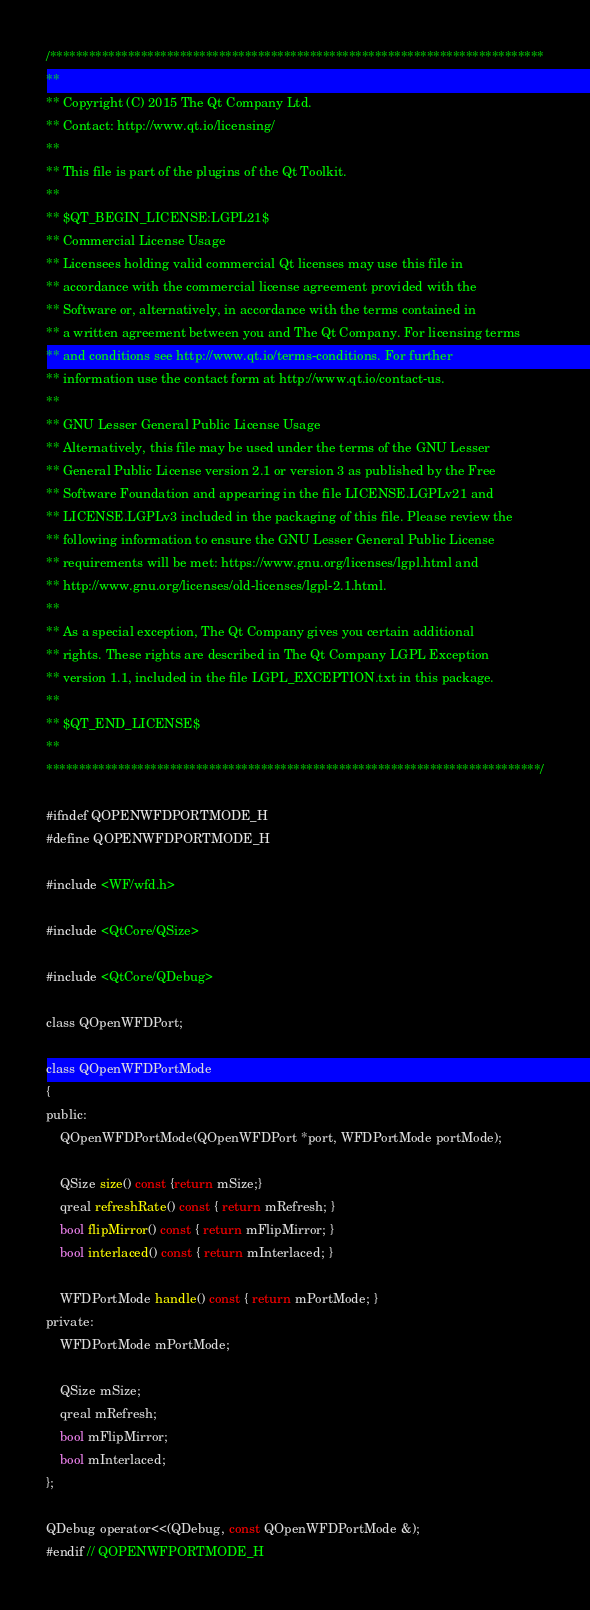Convert code to text. <code><loc_0><loc_0><loc_500><loc_500><_C_>/****************************************************************************
**
** Copyright (C) 2015 The Qt Company Ltd.
** Contact: http://www.qt.io/licensing/
**
** This file is part of the plugins of the Qt Toolkit.
**
** $QT_BEGIN_LICENSE:LGPL21$
** Commercial License Usage
** Licensees holding valid commercial Qt licenses may use this file in
** accordance with the commercial license agreement provided with the
** Software or, alternatively, in accordance with the terms contained in
** a written agreement between you and The Qt Company. For licensing terms
** and conditions see http://www.qt.io/terms-conditions. For further
** information use the contact form at http://www.qt.io/contact-us.
**
** GNU Lesser General Public License Usage
** Alternatively, this file may be used under the terms of the GNU Lesser
** General Public License version 2.1 or version 3 as published by the Free
** Software Foundation and appearing in the file LICENSE.LGPLv21 and
** LICENSE.LGPLv3 included in the packaging of this file. Please review the
** following information to ensure the GNU Lesser General Public License
** requirements will be met: https://www.gnu.org/licenses/lgpl.html and
** http://www.gnu.org/licenses/old-licenses/lgpl-2.1.html.
**
** As a special exception, The Qt Company gives you certain additional
** rights. These rights are described in The Qt Company LGPL Exception
** version 1.1, included in the file LGPL_EXCEPTION.txt in this package.
**
** $QT_END_LICENSE$
**
****************************************************************************/

#ifndef QOPENWFDPORTMODE_H
#define QOPENWFDPORTMODE_H

#include <WF/wfd.h>

#include <QtCore/QSize>

#include <QtCore/QDebug>

class QOpenWFDPort;

class QOpenWFDPortMode
{
public:
    QOpenWFDPortMode(QOpenWFDPort *port, WFDPortMode portMode);

    QSize size() const {return mSize;}
    qreal refreshRate() const { return mRefresh; }
    bool flipMirror() const { return mFlipMirror; }
    bool interlaced() const { return mInterlaced; }

    WFDPortMode handle() const { return mPortMode; }
private:
    WFDPortMode mPortMode;

    QSize mSize;
    qreal mRefresh;
    bool mFlipMirror;
    bool mInterlaced;
};

QDebug operator<<(QDebug, const QOpenWFDPortMode &);
#endif // QOPENWFPORTMODE_H
</code> 